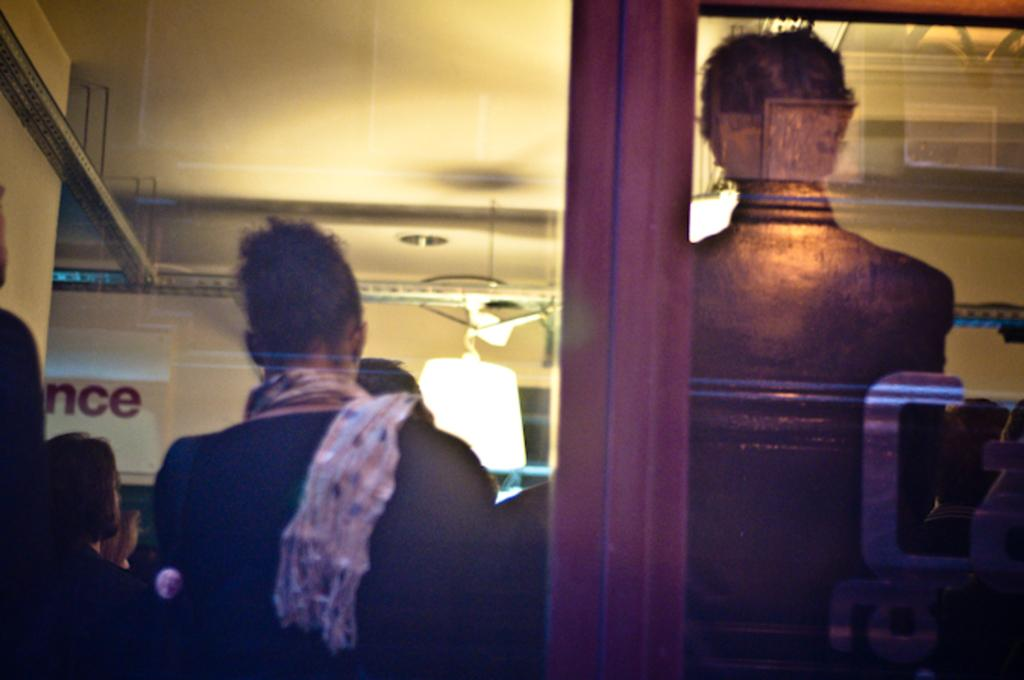What type of wall is visible in the image? There is a glass wall in the image. Where are the people located in the image? The people are in the bottom left of the image. What can be seen in the middle of the image? There is a light in the middle of the image. What is at the top of the image? There is a ceiling at the top of the image. Can you see a copy of the glass wall in the image? There is no copy of the glass wall present in the image. Is there an airplane flying in the image? There is no airplane visible in the image. 